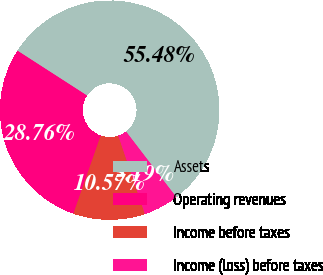Convert chart. <chart><loc_0><loc_0><loc_500><loc_500><pie_chart><fcel>Assets<fcel>Operating revenues<fcel>Income before taxes<fcel>Income (loss) before taxes<nl><fcel>55.48%<fcel>28.76%<fcel>10.57%<fcel>5.19%<nl></chart> 